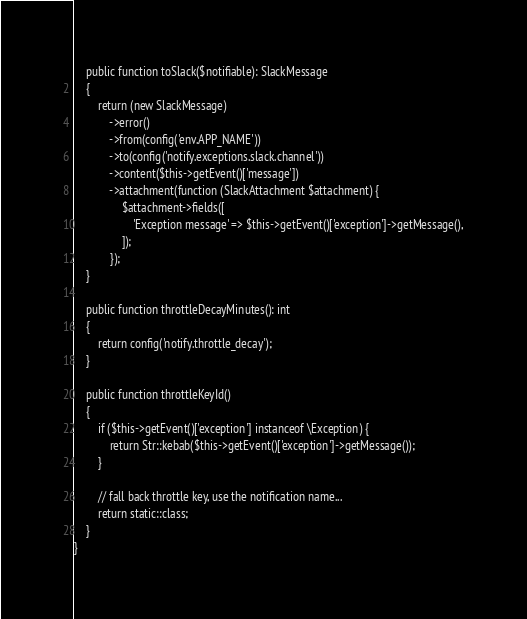Convert code to text. <code><loc_0><loc_0><loc_500><loc_500><_PHP_>    public function toSlack($notifiable): SlackMessage
    {
        return (new SlackMessage)
            ->error()
            ->from(config('env.APP_NAME'))
            ->to(config('notify.exceptions.slack.channel'))
            ->content($this->getEvent()['message'])
            ->attachment(function (SlackAttachment $attachment) {
                $attachment->fields([
                    'Exception message' => $this->getEvent()['exception']->getMessage(),
                ]);
            });
    }

    public function throttleDecayMinutes(): int
    {
        return config('notify.throttle_decay');
    }

    public function throttleKeyId()
    {
        if ($this->getEvent()['exception'] instanceof \Exception) {
            return Str::kebab($this->getEvent()['exception']->getMessage());
        }

        // fall back throttle key, use the notification name...
        return static::class;
    }
}
</code> 